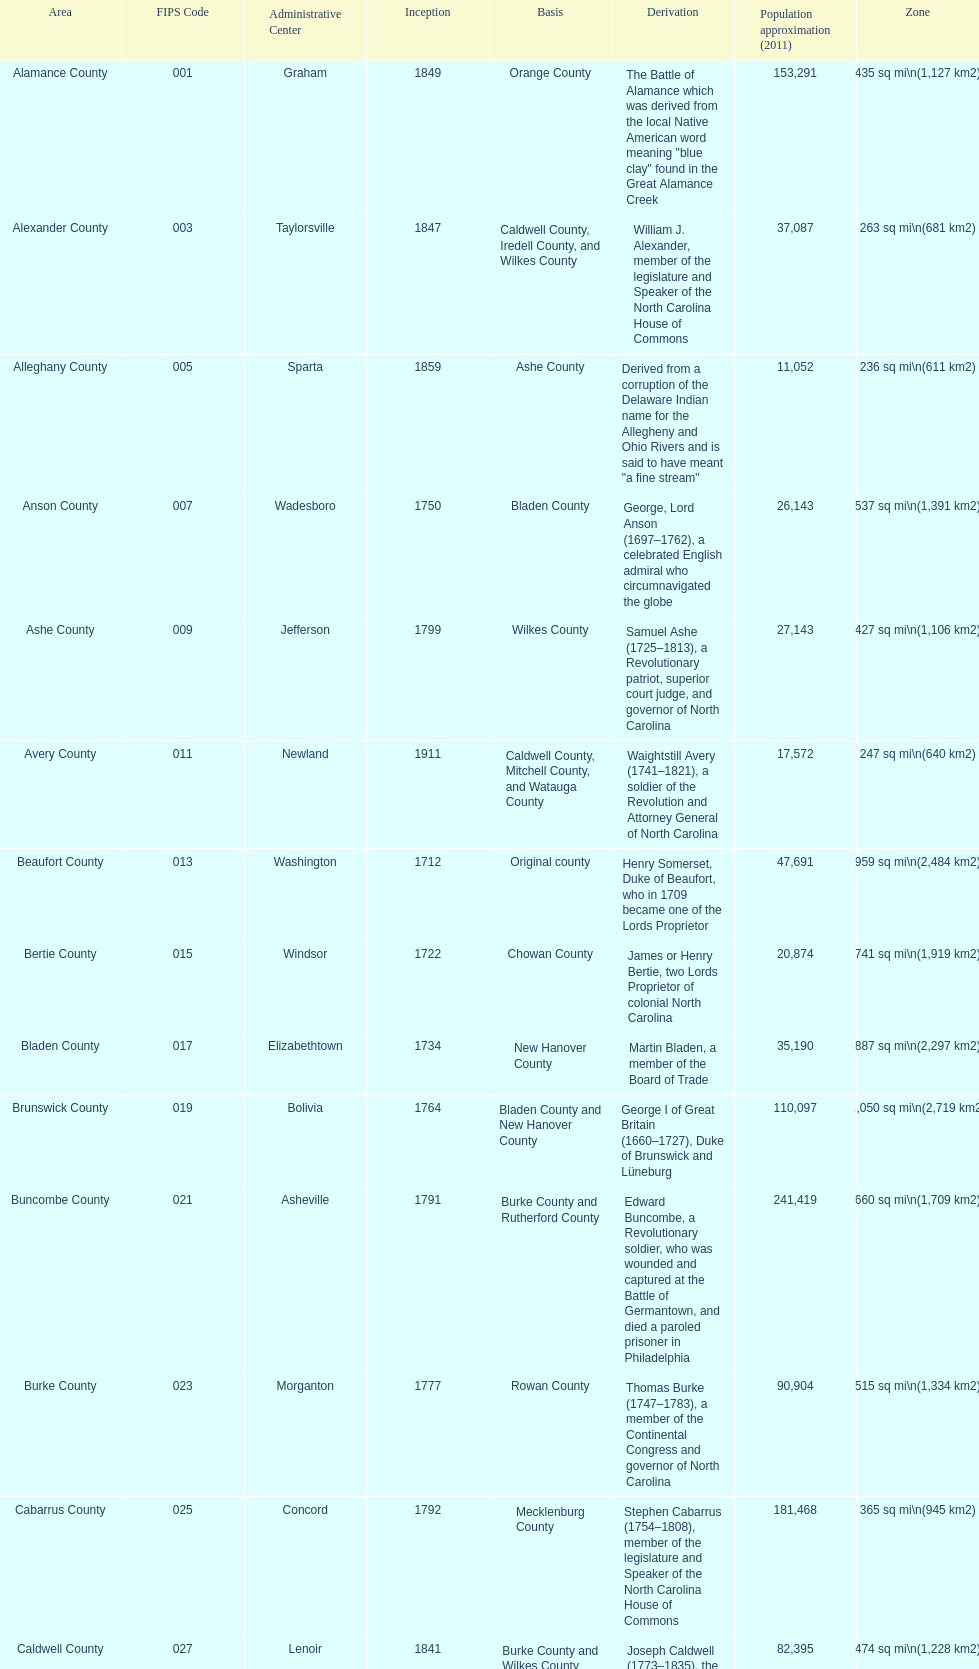What is the number of counties created in the 1800s? 37. 